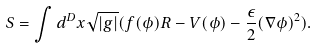Convert formula to latex. <formula><loc_0><loc_0><loc_500><loc_500>S = \int d ^ { D } x \sqrt { | g | } ( f ( \phi ) R - V ( \phi ) - \frac { \epsilon } { 2 } ( \nabla \phi ) ^ { 2 } ) .</formula> 